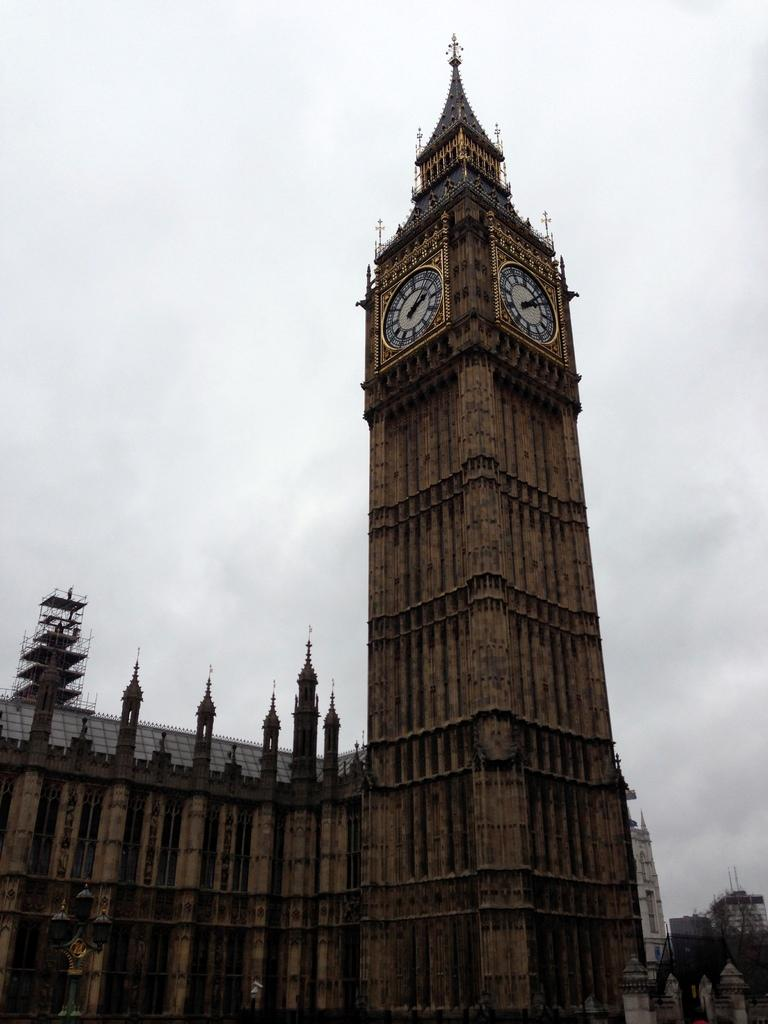What type of natural elements can be seen in the image? There are trees in the image. What type of man-made structures are present in the image? There are buildings in the image. What specific feature can be seen on the buildings in the image? There are clocks on a tower in the image. How many chairs are visible in the image? There are no chairs present in the image. What advice might your uncle give you in the image? There is no uncle present in the image, so it is not possible to determine what advice he might give. 